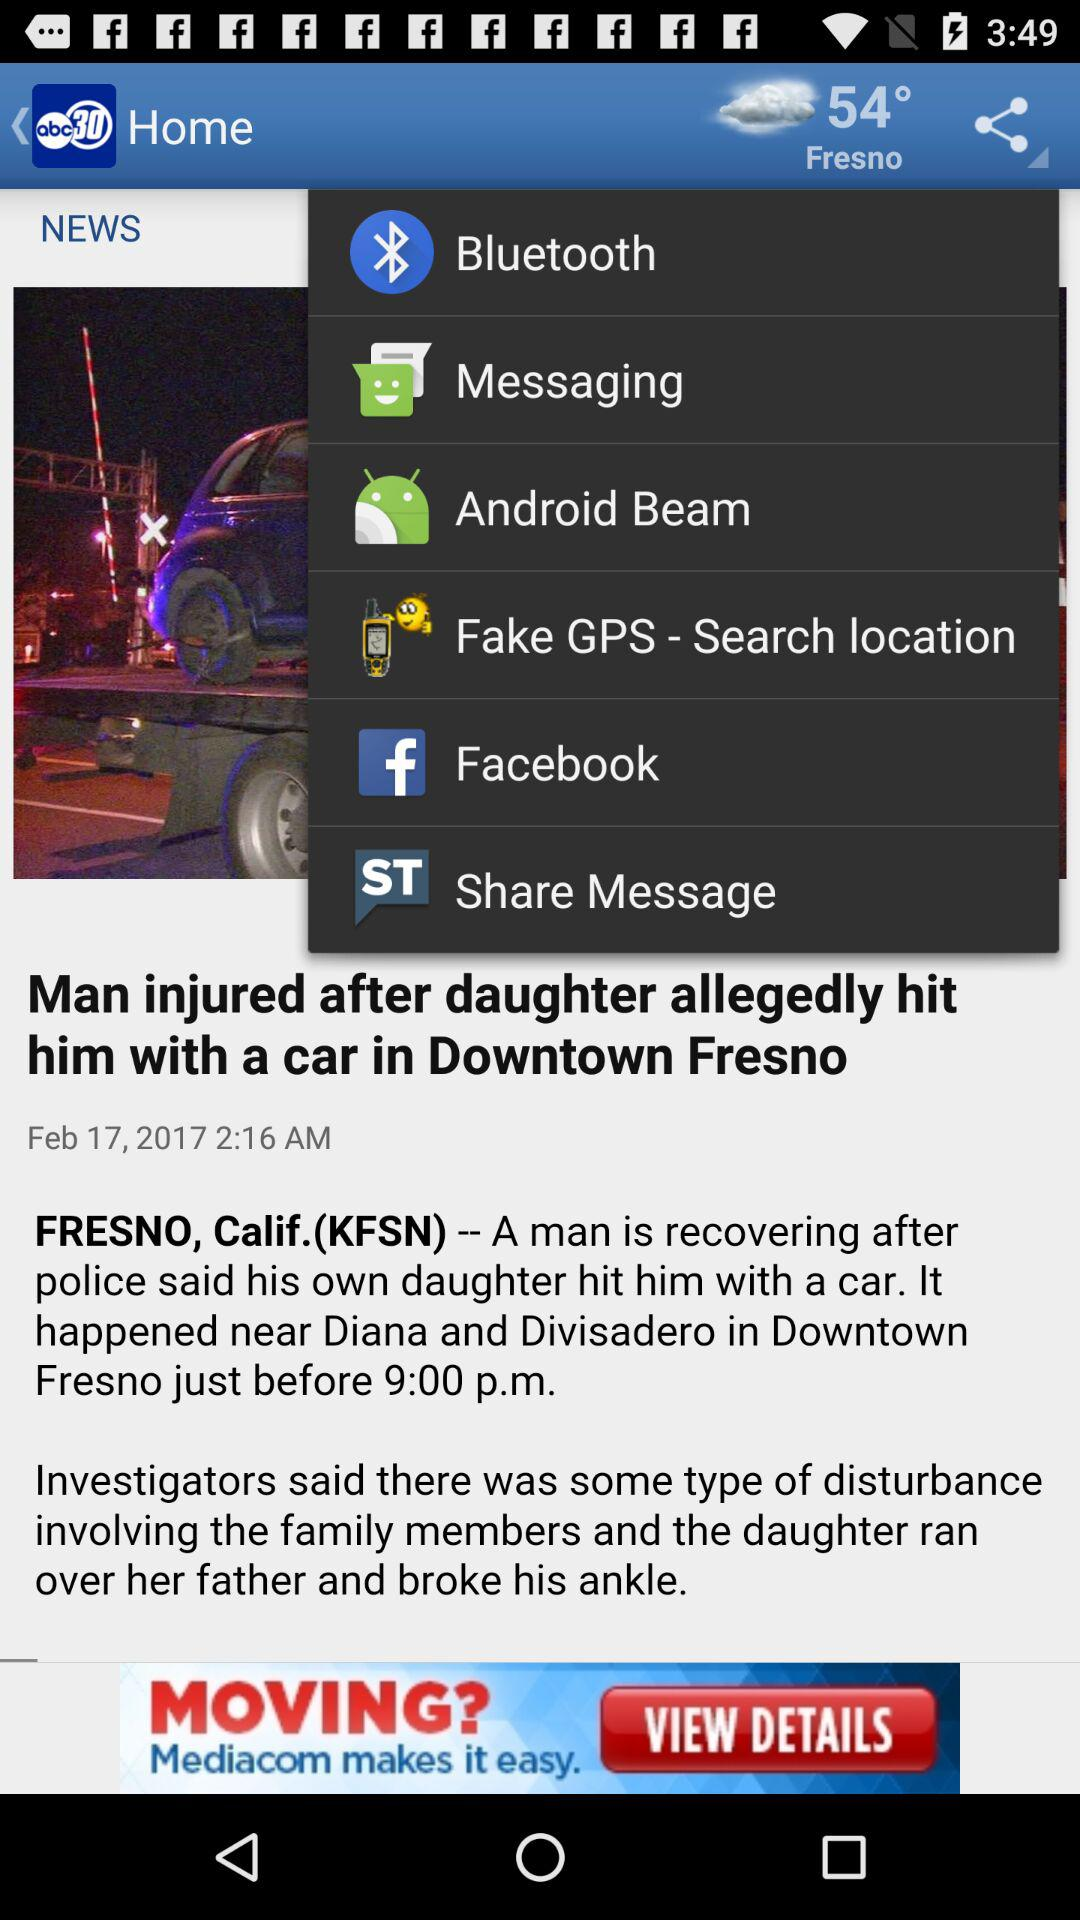What city is mentioned? The mentioned city is Fresno. 